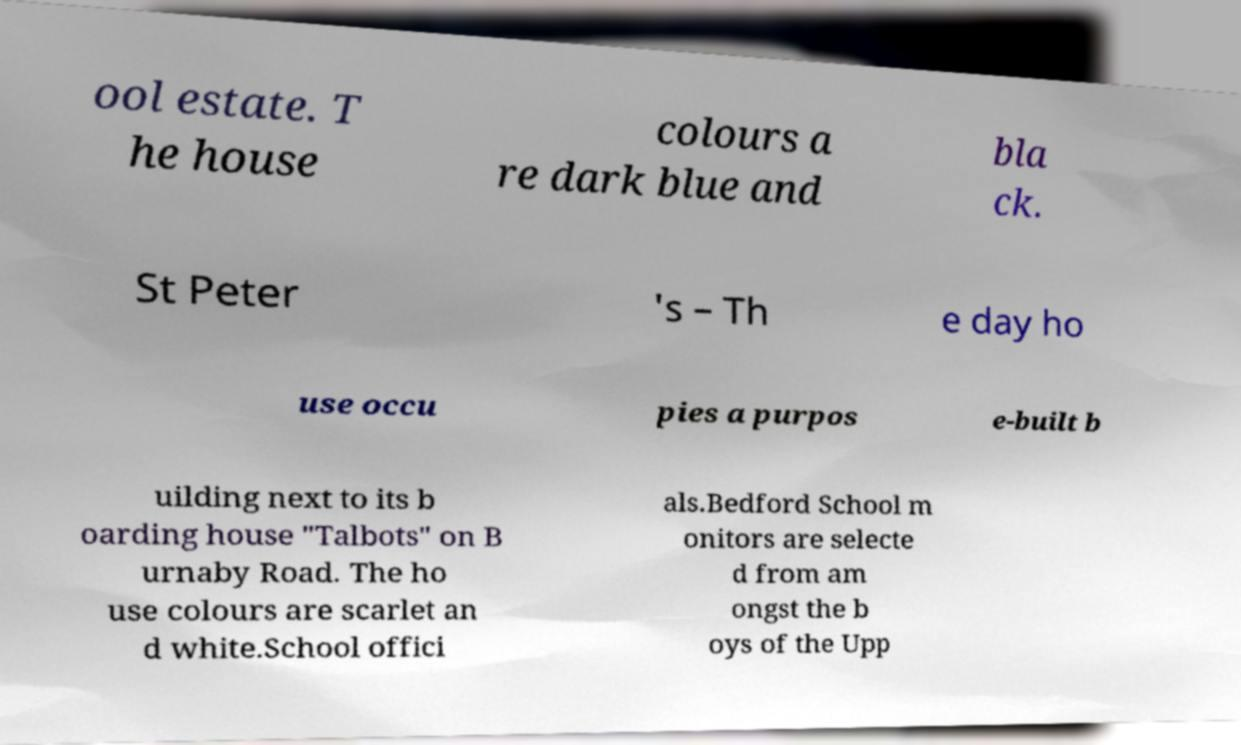There's text embedded in this image that I need extracted. Can you transcribe it verbatim? ool estate. T he house colours a re dark blue and bla ck. St Peter 's – Th e day ho use occu pies a purpos e-built b uilding next to its b oarding house "Talbots" on B urnaby Road. The ho use colours are scarlet an d white.School offici als.Bedford School m onitors are selecte d from am ongst the b oys of the Upp 